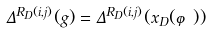Convert formula to latex. <formula><loc_0><loc_0><loc_500><loc_500>\Delta ^ { R _ { D } ( i , j ) } ( g ) = \Delta ^ { R _ { D } ( i , j ) } ( x _ { D } ( \varphi ) )</formula> 